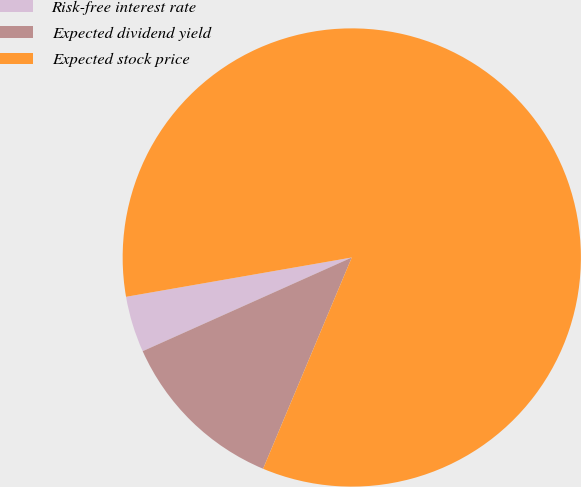Convert chart. <chart><loc_0><loc_0><loc_500><loc_500><pie_chart><fcel>Risk-free interest rate<fcel>Expected dividend yield<fcel>Expected stock price<nl><fcel>3.96%<fcel>11.97%<fcel>84.07%<nl></chart> 